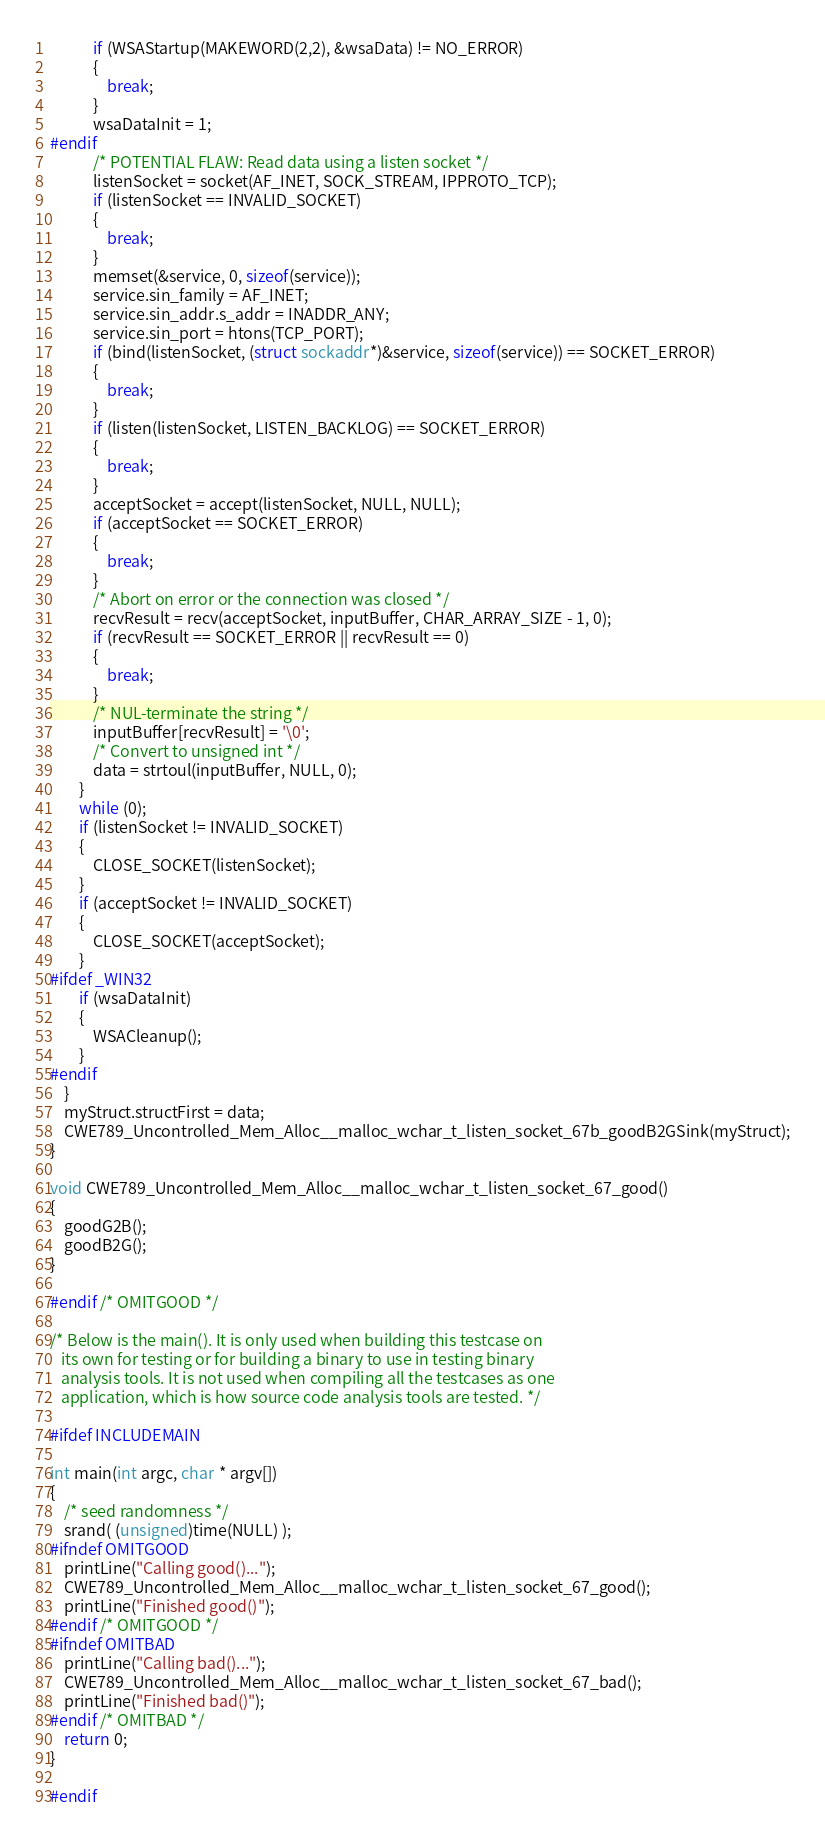<code> <loc_0><loc_0><loc_500><loc_500><_C_>            if (WSAStartup(MAKEWORD(2,2), &wsaData) != NO_ERROR)
            {
                break;
            }
            wsaDataInit = 1;
#endif
            /* POTENTIAL FLAW: Read data using a listen socket */
            listenSocket = socket(AF_INET, SOCK_STREAM, IPPROTO_TCP);
            if (listenSocket == INVALID_SOCKET)
            {
                break;
            }
            memset(&service, 0, sizeof(service));
            service.sin_family = AF_INET;
            service.sin_addr.s_addr = INADDR_ANY;
            service.sin_port = htons(TCP_PORT);
            if (bind(listenSocket, (struct sockaddr*)&service, sizeof(service)) == SOCKET_ERROR)
            {
                break;
            }
            if (listen(listenSocket, LISTEN_BACKLOG) == SOCKET_ERROR)
            {
                break;
            }
            acceptSocket = accept(listenSocket, NULL, NULL);
            if (acceptSocket == SOCKET_ERROR)
            {
                break;
            }
            /* Abort on error or the connection was closed */
            recvResult = recv(acceptSocket, inputBuffer, CHAR_ARRAY_SIZE - 1, 0);
            if (recvResult == SOCKET_ERROR || recvResult == 0)
            {
                break;
            }
            /* NUL-terminate the string */
            inputBuffer[recvResult] = '\0';
            /* Convert to unsigned int */
            data = strtoul(inputBuffer, NULL, 0);
        }
        while (0);
        if (listenSocket != INVALID_SOCKET)
        {
            CLOSE_SOCKET(listenSocket);
        }
        if (acceptSocket != INVALID_SOCKET)
        {
            CLOSE_SOCKET(acceptSocket);
        }
#ifdef _WIN32
        if (wsaDataInit)
        {
            WSACleanup();
        }
#endif
    }
    myStruct.structFirst = data;
    CWE789_Uncontrolled_Mem_Alloc__malloc_wchar_t_listen_socket_67b_goodB2GSink(myStruct);
}

void CWE789_Uncontrolled_Mem_Alloc__malloc_wchar_t_listen_socket_67_good()
{
    goodG2B();
    goodB2G();
}

#endif /* OMITGOOD */

/* Below is the main(). It is only used when building this testcase on
   its own for testing or for building a binary to use in testing binary
   analysis tools. It is not used when compiling all the testcases as one
   application, which is how source code analysis tools are tested. */

#ifdef INCLUDEMAIN

int main(int argc, char * argv[])
{
    /* seed randomness */
    srand( (unsigned)time(NULL) );
#ifndef OMITGOOD
    printLine("Calling good()...");
    CWE789_Uncontrolled_Mem_Alloc__malloc_wchar_t_listen_socket_67_good();
    printLine("Finished good()");
#endif /* OMITGOOD */
#ifndef OMITBAD
    printLine("Calling bad()...");
    CWE789_Uncontrolled_Mem_Alloc__malloc_wchar_t_listen_socket_67_bad();
    printLine("Finished bad()");
#endif /* OMITBAD */
    return 0;
}

#endif
</code> 